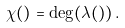Convert formula to latex. <formula><loc_0><loc_0><loc_500><loc_500>\chi ( \L ) = \deg ( \lambda ( \L ) ) \, .</formula> 